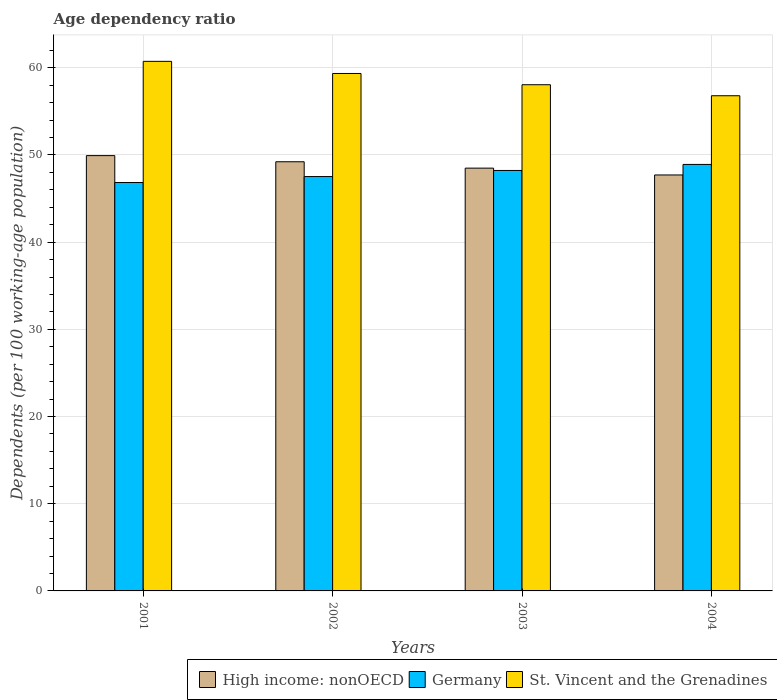How many different coloured bars are there?
Make the answer very short. 3. How many groups of bars are there?
Give a very brief answer. 4. Are the number of bars on each tick of the X-axis equal?
Ensure brevity in your answer.  Yes. How many bars are there on the 1st tick from the left?
Your answer should be very brief. 3. How many bars are there on the 3rd tick from the right?
Ensure brevity in your answer.  3. What is the age dependency ratio in in High income: nonOECD in 2002?
Give a very brief answer. 49.22. Across all years, what is the maximum age dependency ratio in in High income: nonOECD?
Your response must be concise. 49.92. Across all years, what is the minimum age dependency ratio in in High income: nonOECD?
Your answer should be compact. 47.7. In which year was the age dependency ratio in in Germany minimum?
Provide a short and direct response. 2001. What is the total age dependency ratio in in St. Vincent and the Grenadines in the graph?
Provide a succinct answer. 234.91. What is the difference between the age dependency ratio in in Germany in 2002 and that in 2003?
Provide a short and direct response. -0.7. What is the difference between the age dependency ratio in in Germany in 2003 and the age dependency ratio in in High income: nonOECD in 2001?
Your answer should be compact. -1.7. What is the average age dependency ratio in in High income: nonOECD per year?
Provide a short and direct response. 48.83. In the year 2004, what is the difference between the age dependency ratio in in High income: nonOECD and age dependency ratio in in St. Vincent and the Grenadines?
Make the answer very short. -9.08. In how many years, is the age dependency ratio in in St. Vincent and the Grenadines greater than 36 %?
Offer a very short reply. 4. What is the ratio of the age dependency ratio in in Germany in 2001 to that in 2002?
Your answer should be compact. 0.99. What is the difference between the highest and the second highest age dependency ratio in in St. Vincent and the Grenadines?
Give a very brief answer. 1.39. What is the difference between the highest and the lowest age dependency ratio in in St. Vincent and the Grenadines?
Ensure brevity in your answer.  3.94. In how many years, is the age dependency ratio in in Germany greater than the average age dependency ratio in in Germany taken over all years?
Provide a succinct answer. 2. Is the sum of the age dependency ratio in in High income: nonOECD in 2003 and 2004 greater than the maximum age dependency ratio in in St. Vincent and the Grenadines across all years?
Give a very brief answer. Yes. What does the 3rd bar from the left in 2001 represents?
Ensure brevity in your answer.  St. Vincent and the Grenadines. What does the 1st bar from the right in 2002 represents?
Provide a short and direct response. St. Vincent and the Grenadines. Are all the bars in the graph horizontal?
Provide a short and direct response. No. How many years are there in the graph?
Your answer should be compact. 4. Are the values on the major ticks of Y-axis written in scientific E-notation?
Offer a very short reply. No. Does the graph contain grids?
Provide a succinct answer. Yes. Where does the legend appear in the graph?
Give a very brief answer. Bottom right. How many legend labels are there?
Ensure brevity in your answer.  3. How are the legend labels stacked?
Your answer should be compact. Horizontal. What is the title of the graph?
Ensure brevity in your answer.  Age dependency ratio. Does "Burundi" appear as one of the legend labels in the graph?
Provide a succinct answer. No. What is the label or title of the X-axis?
Offer a terse response. Years. What is the label or title of the Y-axis?
Give a very brief answer. Dependents (per 100 working-age population). What is the Dependents (per 100 working-age population) in High income: nonOECD in 2001?
Keep it short and to the point. 49.92. What is the Dependents (per 100 working-age population) in Germany in 2001?
Offer a very short reply. 46.84. What is the Dependents (per 100 working-age population) in St. Vincent and the Grenadines in 2001?
Your response must be concise. 60.73. What is the Dependents (per 100 working-age population) of High income: nonOECD in 2002?
Offer a very short reply. 49.22. What is the Dependents (per 100 working-age population) of Germany in 2002?
Give a very brief answer. 47.52. What is the Dependents (per 100 working-age population) of St. Vincent and the Grenadines in 2002?
Your response must be concise. 59.34. What is the Dependents (per 100 working-age population) of High income: nonOECD in 2003?
Provide a short and direct response. 48.49. What is the Dependents (per 100 working-age population) of Germany in 2003?
Make the answer very short. 48.22. What is the Dependents (per 100 working-age population) in St. Vincent and the Grenadines in 2003?
Your response must be concise. 58.05. What is the Dependents (per 100 working-age population) of High income: nonOECD in 2004?
Provide a succinct answer. 47.7. What is the Dependents (per 100 working-age population) of Germany in 2004?
Give a very brief answer. 48.91. What is the Dependents (per 100 working-age population) of St. Vincent and the Grenadines in 2004?
Keep it short and to the point. 56.79. Across all years, what is the maximum Dependents (per 100 working-age population) in High income: nonOECD?
Make the answer very short. 49.92. Across all years, what is the maximum Dependents (per 100 working-age population) of Germany?
Your response must be concise. 48.91. Across all years, what is the maximum Dependents (per 100 working-age population) of St. Vincent and the Grenadines?
Provide a short and direct response. 60.73. Across all years, what is the minimum Dependents (per 100 working-age population) in High income: nonOECD?
Give a very brief answer. 47.7. Across all years, what is the minimum Dependents (per 100 working-age population) in Germany?
Your answer should be very brief. 46.84. Across all years, what is the minimum Dependents (per 100 working-age population) in St. Vincent and the Grenadines?
Your answer should be compact. 56.79. What is the total Dependents (per 100 working-age population) in High income: nonOECD in the graph?
Provide a short and direct response. 195.33. What is the total Dependents (per 100 working-age population) of Germany in the graph?
Provide a succinct answer. 191.48. What is the total Dependents (per 100 working-age population) in St. Vincent and the Grenadines in the graph?
Make the answer very short. 234.91. What is the difference between the Dependents (per 100 working-age population) of High income: nonOECD in 2001 and that in 2002?
Give a very brief answer. 0.7. What is the difference between the Dependents (per 100 working-age population) in Germany in 2001 and that in 2002?
Your answer should be very brief. -0.68. What is the difference between the Dependents (per 100 working-age population) of St. Vincent and the Grenadines in 2001 and that in 2002?
Ensure brevity in your answer.  1.39. What is the difference between the Dependents (per 100 working-age population) in High income: nonOECD in 2001 and that in 2003?
Give a very brief answer. 1.43. What is the difference between the Dependents (per 100 working-age population) of Germany in 2001 and that in 2003?
Make the answer very short. -1.38. What is the difference between the Dependents (per 100 working-age population) in St. Vincent and the Grenadines in 2001 and that in 2003?
Make the answer very short. 2.68. What is the difference between the Dependents (per 100 working-age population) in High income: nonOECD in 2001 and that in 2004?
Keep it short and to the point. 2.22. What is the difference between the Dependents (per 100 working-age population) of Germany in 2001 and that in 2004?
Offer a terse response. -2.07. What is the difference between the Dependents (per 100 working-age population) in St. Vincent and the Grenadines in 2001 and that in 2004?
Offer a very short reply. 3.94. What is the difference between the Dependents (per 100 working-age population) in High income: nonOECD in 2002 and that in 2003?
Keep it short and to the point. 0.73. What is the difference between the Dependents (per 100 working-age population) of Germany in 2002 and that in 2003?
Make the answer very short. -0.7. What is the difference between the Dependents (per 100 working-age population) in St. Vincent and the Grenadines in 2002 and that in 2003?
Offer a terse response. 1.29. What is the difference between the Dependents (per 100 working-age population) in High income: nonOECD in 2002 and that in 2004?
Provide a succinct answer. 1.51. What is the difference between the Dependents (per 100 working-age population) of Germany in 2002 and that in 2004?
Provide a short and direct response. -1.39. What is the difference between the Dependents (per 100 working-age population) of St. Vincent and the Grenadines in 2002 and that in 2004?
Your response must be concise. 2.55. What is the difference between the Dependents (per 100 working-age population) in High income: nonOECD in 2003 and that in 2004?
Your answer should be very brief. 0.78. What is the difference between the Dependents (per 100 working-age population) of Germany in 2003 and that in 2004?
Keep it short and to the point. -0.69. What is the difference between the Dependents (per 100 working-age population) in St. Vincent and the Grenadines in 2003 and that in 2004?
Keep it short and to the point. 1.26. What is the difference between the Dependents (per 100 working-age population) of High income: nonOECD in 2001 and the Dependents (per 100 working-age population) of Germany in 2002?
Give a very brief answer. 2.4. What is the difference between the Dependents (per 100 working-age population) in High income: nonOECD in 2001 and the Dependents (per 100 working-age population) in St. Vincent and the Grenadines in 2002?
Keep it short and to the point. -9.42. What is the difference between the Dependents (per 100 working-age population) in Germany in 2001 and the Dependents (per 100 working-age population) in St. Vincent and the Grenadines in 2002?
Your response must be concise. -12.51. What is the difference between the Dependents (per 100 working-age population) of High income: nonOECD in 2001 and the Dependents (per 100 working-age population) of Germany in 2003?
Ensure brevity in your answer.  1.7. What is the difference between the Dependents (per 100 working-age population) of High income: nonOECD in 2001 and the Dependents (per 100 working-age population) of St. Vincent and the Grenadines in 2003?
Keep it short and to the point. -8.13. What is the difference between the Dependents (per 100 working-age population) in Germany in 2001 and the Dependents (per 100 working-age population) in St. Vincent and the Grenadines in 2003?
Keep it short and to the point. -11.22. What is the difference between the Dependents (per 100 working-age population) of High income: nonOECD in 2001 and the Dependents (per 100 working-age population) of Germany in 2004?
Ensure brevity in your answer.  1.01. What is the difference between the Dependents (per 100 working-age population) of High income: nonOECD in 2001 and the Dependents (per 100 working-age population) of St. Vincent and the Grenadines in 2004?
Your answer should be compact. -6.87. What is the difference between the Dependents (per 100 working-age population) in Germany in 2001 and the Dependents (per 100 working-age population) in St. Vincent and the Grenadines in 2004?
Ensure brevity in your answer.  -9.95. What is the difference between the Dependents (per 100 working-age population) in High income: nonOECD in 2002 and the Dependents (per 100 working-age population) in St. Vincent and the Grenadines in 2003?
Offer a terse response. -8.83. What is the difference between the Dependents (per 100 working-age population) of Germany in 2002 and the Dependents (per 100 working-age population) of St. Vincent and the Grenadines in 2003?
Make the answer very short. -10.53. What is the difference between the Dependents (per 100 working-age population) in High income: nonOECD in 2002 and the Dependents (per 100 working-age population) in Germany in 2004?
Give a very brief answer. 0.31. What is the difference between the Dependents (per 100 working-age population) of High income: nonOECD in 2002 and the Dependents (per 100 working-age population) of St. Vincent and the Grenadines in 2004?
Keep it short and to the point. -7.57. What is the difference between the Dependents (per 100 working-age population) of Germany in 2002 and the Dependents (per 100 working-age population) of St. Vincent and the Grenadines in 2004?
Provide a succinct answer. -9.27. What is the difference between the Dependents (per 100 working-age population) in High income: nonOECD in 2003 and the Dependents (per 100 working-age population) in Germany in 2004?
Offer a very short reply. -0.42. What is the difference between the Dependents (per 100 working-age population) in High income: nonOECD in 2003 and the Dependents (per 100 working-age population) in St. Vincent and the Grenadines in 2004?
Give a very brief answer. -8.3. What is the difference between the Dependents (per 100 working-age population) in Germany in 2003 and the Dependents (per 100 working-age population) in St. Vincent and the Grenadines in 2004?
Keep it short and to the point. -8.57. What is the average Dependents (per 100 working-age population) of High income: nonOECD per year?
Your response must be concise. 48.83. What is the average Dependents (per 100 working-age population) in Germany per year?
Give a very brief answer. 47.87. What is the average Dependents (per 100 working-age population) of St. Vincent and the Grenadines per year?
Offer a terse response. 58.73. In the year 2001, what is the difference between the Dependents (per 100 working-age population) of High income: nonOECD and Dependents (per 100 working-age population) of Germany?
Provide a succinct answer. 3.09. In the year 2001, what is the difference between the Dependents (per 100 working-age population) of High income: nonOECD and Dependents (per 100 working-age population) of St. Vincent and the Grenadines?
Make the answer very short. -10.81. In the year 2001, what is the difference between the Dependents (per 100 working-age population) of Germany and Dependents (per 100 working-age population) of St. Vincent and the Grenadines?
Ensure brevity in your answer.  -13.9. In the year 2002, what is the difference between the Dependents (per 100 working-age population) of High income: nonOECD and Dependents (per 100 working-age population) of Germany?
Offer a terse response. 1.7. In the year 2002, what is the difference between the Dependents (per 100 working-age population) in High income: nonOECD and Dependents (per 100 working-age population) in St. Vincent and the Grenadines?
Provide a succinct answer. -10.12. In the year 2002, what is the difference between the Dependents (per 100 working-age population) in Germany and Dependents (per 100 working-age population) in St. Vincent and the Grenadines?
Your response must be concise. -11.82. In the year 2003, what is the difference between the Dependents (per 100 working-age population) in High income: nonOECD and Dependents (per 100 working-age population) in Germany?
Provide a short and direct response. 0.27. In the year 2003, what is the difference between the Dependents (per 100 working-age population) in High income: nonOECD and Dependents (per 100 working-age population) in St. Vincent and the Grenadines?
Your response must be concise. -9.57. In the year 2003, what is the difference between the Dependents (per 100 working-age population) in Germany and Dependents (per 100 working-age population) in St. Vincent and the Grenadines?
Ensure brevity in your answer.  -9.83. In the year 2004, what is the difference between the Dependents (per 100 working-age population) of High income: nonOECD and Dependents (per 100 working-age population) of Germany?
Your answer should be compact. -1.21. In the year 2004, what is the difference between the Dependents (per 100 working-age population) of High income: nonOECD and Dependents (per 100 working-age population) of St. Vincent and the Grenadines?
Your response must be concise. -9.08. In the year 2004, what is the difference between the Dependents (per 100 working-age population) of Germany and Dependents (per 100 working-age population) of St. Vincent and the Grenadines?
Provide a short and direct response. -7.88. What is the ratio of the Dependents (per 100 working-age population) of High income: nonOECD in 2001 to that in 2002?
Your answer should be compact. 1.01. What is the ratio of the Dependents (per 100 working-age population) of Germany in 2001 to that in 2002?
Provide a short and direct response. 0.99. What is the ratio of the Dependents (per 100 working-age population) in St. Vincent and the Grenadines in 2001 to that in 2002?
Your answer should be compact. 1.02. What is the ratio of the Dependents (per 100 working-age population) of High income: nonOECD in 2001 to that in 2003?
Make the answer very short. 1.03. What is the ratio of the Dependents (per 100 working-age population) in Germany in 2001 to that in 2003?
Keep it short and to the point. 0.97. What is the ratio of the Dependents (per 100 working-age population) in St. Vincent and the Grenadines in 2001 to that in 2003?
Your answer should be very brief. 1.05. What is the ratio of the Dependents (per 100 working-age population) in High income: nonOECD in 2001 to that in 2004?
Ensure brevity in your answer.  1.05. What is the ratio of the Dependents (per 100 working-age population) in Germany in 2001 to that in 2004?
Provide a short and direct response. 0.96. What is the ratio of the Dependents (per 100 working-age population) in St. Vincent and the Grenadines in 2001 to that in 2004?
Offer a terse response. 1.07. What is the ratio of the Dependents (per 100 working-age population) in High income: nonOECD in 2002 to that in 2003?
Keep it short and to the point. 1.02. What is the ratio of the Dependents (per 100 working-age population) of Germany in 2002 to that in 2003?
Your response must be concise. 0.99. What is the ratio of the Dependents (per 100 working-age population) of St. Vincent and the Grenadines in 2002 to that in 2003?
Offer a terse response. 1.02. What is the ratio of the Dependents (per 100 working-age population) of High income: nonOECD in 2002 to that in 2004?
Give a very brief answer. 1.03. What is the ratio of the Dependents (per 100 working-age population) of Germany in 2002 to that in 2004?
Make the answer very short. 0.97. What is the ratio of the Dependents (per 100 working-age population) in St. Vincent and the Grenadines in 2002 to that in 2004?
Provide a short and direct response. 1.04. What is the ratio of the Dependents (per 100 working-age population) of High income: nonOECD in 2003 to that in 2004?
Your answer should be very brief. 1.02. What is the ratio of the Dependents (per 100 working-age population) in Germany in 2003 to that in 2004?
Provide a short and direct response. 0.99. What is the ratio of the Dependents (per 100 working-age population) of St. Vincent and the Grenadines in 2003 to that in 2004?
Your answer should be very brief. 1.02. What is the difference between the highest and the second highest Dependents (per 100 working-age population) in High income: nonOECD?
Offer a very short reply. 0.7. What is the difference between the highest and the second highest Dependents (per 100 working-age population) of Germany?
Offer a very short reply. 0.69. What is the difference between the highest and the second highest Dependents (per 100 working-age population) of St. Vincent and the Grenadines?
Your answer should be very brief. 1.39. What is the difference between the highest and the lowest Dependents (per 100 working-age population) in High income: nonOECD?
Give a very brief answer. 2.22. What is the difference between the highest and the lowest Dependents (per 100 working-age population) in Germany?
Give a very brief answer. 2.07. What is the difference between the highest and the lowest Dependents (per 100 working-age population) of St. Vincent and the Grenadines?
Give a very brief answer. 3.94. 